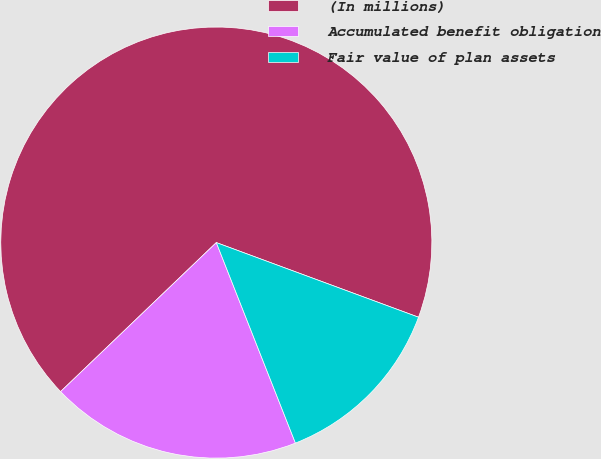Convert chart to OTSL. <chart><loc_0><loc_0><loc_500><loc_500><pie_chart><fcel>(In millions)<fcel>Accumulated benefit obligation<fcel>Fair value of plan assets<nl><fcel>67.78%<fcel>18.83%<fcel>13.39%<nl></chart> 